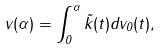<formula> <loc_0><loc_0><loc_500><loc_500>v ( \alpha ) = \int _ { 0 } ^ { \alpha } \tilde { k } ( t ) d v _ { 0 } ( t ) ,</formula> 